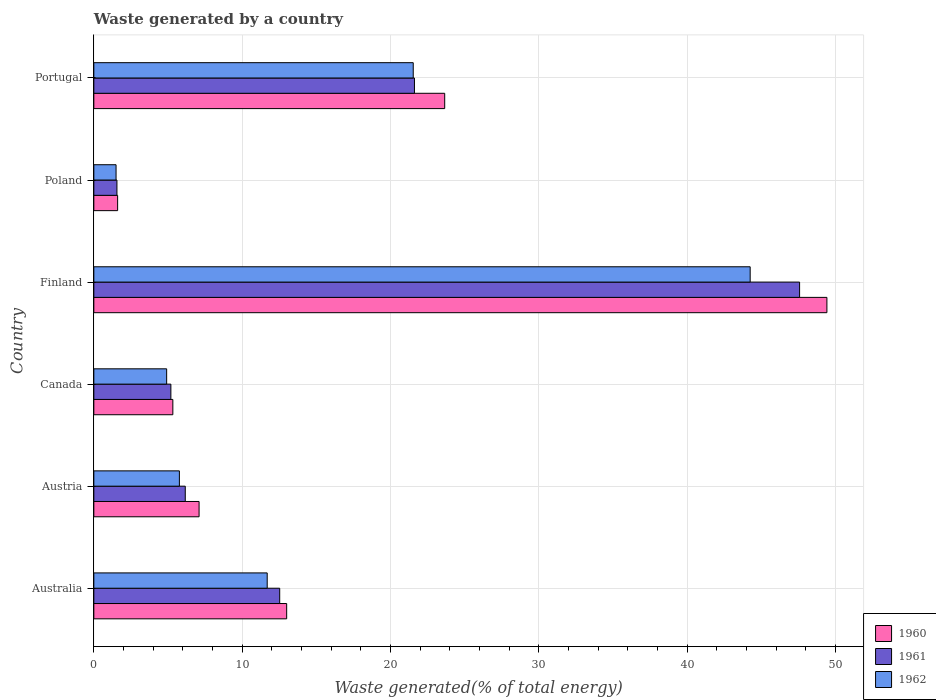Are the number of bars on each tick of the Y-axis equal?
Keep it short and to the point. Yes. How many bars are there on the 3rd tick from the bottom?
Offer a very short reply. 3. What is the label of the 6th group of bars from the top?
Offer a terse response. Australia. In how many cases, is the number of bars for a given country not equal to the number of legend labels?
Provide a short and direct response. 0. What is the total waste generated in 1960 in Finland?
Provide a succinct answer. 49.42. Across all countries, what is the maximum total waste generated in 1962?
Offer a very short reply. 44.25. Across all countries, what is the minimum total waste generated in 1961?
Offer a terse response. 1.56. In which country was the total waste generated in 1960 minimum?
Give a very brief answer. Poland. What is the total total waste generated in 1962 in the graph?
Give a very brief answer. 89.65. What is the difference between the total waste generated in 1960 in Austria and that in Portugal?
Offer a terse response. -16.56. What is the difference between the total waste generated in 1962 in Portugal and the total waste generated in 1960 in Australia?
Keep it short and to the point. 8.53. What is the average total waste generated in 1961 per country?
Your answer should be compact. 15.77. What is the difference between the total waste generated in 1961 and total waste generated in 1960 in Finland?
Provide a succinct answer. -1.84. What is the ratio of the total waste generated in 1960 in Austria to that in Finland?
Offer a very short reply. 0.14. What is the difference between the highest and the second highest total waste generated in 1960?
Make the answer very short. 25.77. What is the difference between the highest and the lowest total waste generated in 1962?
Offer a very short reply. 42.75. Is the sum of the total waste generated in 1962 in Austria and Portugal greater than the maximum total waste generated in 1960 across all countries?
Your answer should be compact. No. Is it the case that in every country, the sum of the total waste generated in 1961 and total waste generated in 1962 is greater than the total waste generated in 1960?
Your answer should be very brief. Yes. How many bars are there?
Offer a terse response. 18. How many countries are there in the graph?
Provide a short and direct response. 6. Does the graph contain grids?
Offer a terse response. Yes. How many legend labels are there?
Ensure brevity in your answer.  3. How are the legend labels stacked?
Your answer should be compact. Vertical. What is the title of the graph?
Provide a succinct answer. Waste generated by a country. Does "2000" appear as one of the legend labels in the graph?
Give a very brief answer. No. What is the label or title of the X-axis?
Give a very brief answer. Waste generated(% of total energy). What is the Waste generated(% of total energy) of 1960 in Australia?
Offer a terse response. 13. What is the Waste generated(% of total energy) in 1961 in Australia?
Offer a terse response. 12.53. What is the Waste generated(% of total energy) in 1962 in Australia?
Make the answer very short. 11.69. What is the Waste generated(% of total energy) in 1960 in Austria?
Offer a terse response. 7.1. What is the Waste generated(% of total energy) of 1961 in Austria?
Keep it short and to the point. 6.16. What is the Waste generated(% of total energy) of 1962 in Austria?
Offer a very short reply. 5.77. What is the Waste generated(% of total energy) of 1960 in Canada?
Your answer should be very brief. 5.33. What is the Waste generated(% of total energy) in 1961 in Canada?
Keep it short and to the point. 5.19. What is the Waste generated(% of total energy) of 1962 in Canada?
Offer a terse response. 4.91. What is the Waste generated(% of total energy) of 1960 in Finland?
Your answer should be compact. 49.42. What is the Waste generated(% of total energy) of 1961 in Finland?
Provide a short and direct response. 47.58. What is the Waste generated(% of total energy) of 1962 in Finland?
Your response must be concise. 44.25. What is the Waste generated(% of total energy) in 1960 in Poland?
Your answer should be very brief. 1.6. What is the Waste generated(% of total energy) of 1961 in Poland?
Provide a succinct answer. 1.56. What is the Waste generated(% of total energy) of 1962 in Poland?
Offer a terse response. 1.5. What is the Waste generated(% of total energy) of 1960 in Portugal?
Your response must be concise. 23.66. What is the Waste generated(% of total energy) of 1961 in Portugal?
Offer a terse response. 21.62. What is the Waste generated(% of total energy) in 1962 in Portugal?
Provide a succinct answer. 21.53. Across all countries, what is the maximum Waste generated(% of total energy) in 1960?
Ensure brevity in your answer.  49.42. Across all countries, what is the maximum Waste generated(% of total energy) of 1961?
Your answer should be compact. 47.58. Across all countries, what is the maximum Waste generated(% of total energy) in 1962?
Your response must be concise. 44.25. Across all countries, what is the minimum Waste generated(% of total energy) in 1960?
Keep it short and to the point. 1.6. Across all countries, what is the minimum Waste generated(% of total energy) in 1961?
Make the answer very short. 1.56. Across all countries, what is the minimum Waste generated(% of total energy) of 1962?
Your answer should be very brief. 1.5. What is the total Waste generated(% of total energy) in 1960 in the graph?
Provide a short and direct response. 100.11. What is the total Waste generated(% of total energy) of 1961 in the graph?
Your response must be concise. 94.65. What is the total Waste generated(% of total energy) in 1962 in the graph?
Make the answer very short. 89.65. What is the difference between the Waste generated(% of total energy) of 1960 in Australia and that in Austria?
Give a very brief answer. 5.9. What is the difference between the Waste generated(% of total energy) of 1961 in Australia and that in Austria?
Provide a short and direct response. 6.37. What is the difference between the Waste generated(% of total energy) in 1962 in Australia and that in Austria?
Give a very brief answer. 5.92. What is the difference between the Waste generated(% of total energy) of 1960 in Australia and that in Canada?
Make the answer very short. 7.67. What is the difference between the Waste generated(% of total energy) of 1961 in Australia and that in Canada?
Keep it short and to the point. 7.34. What is the difference between the Waste generated(% of total energy) of 1962 in Australia and that in Canada?
Give a very brief answer. 6.78. What is the difference between the Waste generated(% of total energy) of 1960 in Australia and that in Finland?
Ensure brevity in your answer.  -36.42. What is the difference between the Waste generated(% of total energy) of 1961 in Australia and that in Finland?
Your response must be concise. -35.05. What is the difference between the Waste generated(% of total energy) of 1962 in Australia and that in Finland?
Your answer should be very brief. -32.56. What is the difference between the Waste generated(% of total energy) of 1960 in Australia and that in Poland?
Provide a succinct answer. 11.4. What is the difference between the Waste generated(% of total energy) in 1961 in Australia and that in Poland?
Your answer should be compact. 10.97. What is the difference between the Waste generated(% of total energy) of 1962 in Australia and that in Poland?
Offer a terse response. 10.19. What is the difference between the Waste generated(% of total energy) in 1960 in Australia and that in Portugal?
Offer a very short reply. -10.65. What is the difference between the Waste generated(% of total energy) of 1961 in Australia and that in Portugal?
Ensure brevity in your answer.  -9.09. What is the difference between the Waste generated(% of total energy) of 1962 in Australia and that in Portugal?
Offer a terse response. -9.84. What is the difference between the Waste generated(% of total energy) in 1960 in Austria and that in Canada?
Offer a very short reply. 1.77. What is the difference between the Waste generated(% of total energy) of 1961 in Austria and that in Canada?
Give a very brief answer. 0.97. What is the difference between the Waste generated(% of total energy) in 1962 in Austria and that in Canada?
Keep it short and to the point. 0.86. What is the difference between the Waste generated(% of total energy) in 1960 in Austria and that in Finland?
Offer a very short reply. -42.33. What is the difference between the Waste generated(% of total energy) in 1961 in Austria and that in Finland?
Provide a succinct answer. -41.42. What is the difference between the Waste generated(% of total energy) in 1962 in Austria and that in Finland?
Give a very brief answer. -38.48. What is the difference between the Waste generated(% of total energy) of 1960 in Austria and that in Poland?
Keep it short and to the point. 5.49. What is the difference between the Waste generated(% of total energy) in 1961 in Austria and that in Poland?
Make the answer very short. 4.61. What is the difference between the Waste generated(% of total energy) in 1962 in Austria and that in Poland?
Your response must be concise. 4.27. What is the difference between the Waste generated(% of total energy) in 1960 in Austria and that in Portugal?
Offer a terse response. -16.56. What is the difference between the Waste generated(% of total energy) of 1961 in Austria and that in Portugal?
Keep it short and to the point. -15.45. What is the difference between the Waste generated(% of total energy) in 1962 in Austria and that in Portugal?
Offer a terse response. -15.76. What is the difference between the Waste generated(% of total energy) in 1960 in Canada and that in Finland?
Your answer should be very brief. -44.1. What is the difference between the Waste generated(% of total energy) of 1961 in Canada and that in Finland?
Offer a very short reply. -42.39. What is the difference between the Waste generated(% of total energy) in 1962 in Canada and that in Finland?
Provide a short and direct response. -39.34. What is the difference between the Waste generated(% of total energy) of 1960 in Canada and that in Poland?
Offer a terse response. 3.72. What is the difference between the Waste generated(% of total energy) in 1961 in Canada and that in Poland?
Offer a very short reply. 3.64. What is the difference between the Waste generated(% of total energy) in 1962 in Canada and that in Poland?
Make the answer very short. 3.41. What is the difference between the Waste generated(% of total energy) in 1960 in Canada and that in Portugal?
Give a very brief answer. -18.33. What is the difference between the Waste generated(% of total energy) of 1961 in Canada and that in Portugal?
Offer a terse response. -16.42. What is the difference between the Waste generated(% of total energy) of 1962 in Canada and that in Portugal?
Provide a succinct answer. -16.62. What is the difference between the Waste generated(% of total energy) in 1960 in Finland and that in Poland?
Make the answer very short. 47.82. What is the difference between the Waste generated(% of total energy) in 1961 in Finland and that in Poland?
Provide a short and direct response. 46.02. What is the difference between the Waste generated(% of total energy) of 1962 in Finland and that in Poland?
Your answer should be compact. 42.75. What is the difference between the Waste generated(% of total energy) in 1960 in Finland and that in Portugal?
Offer a very short reply. 25.77. What is the difference between the Waste generated(% of total energy) of 1961 in Finland and that in Portugal?
Your response must be concise. 25.96. What is the difference between the Waste generated(% of total energy) in 1962 in Finland and that in Portugal?
Offer a terse response. 22.72. What is the difference between the Waste generated(% of total energy) of 1960 in Poland and that in Portugal?
Offer a very short reply. -22.05. What is the difference between the Waste generated(% of total energy) of 1961 in Poland and that in Portugal?
Make the answer very short. -20.06. What is the difference between the Waste generated(% of total energy) in 1962 in Poland and that in Portugal?
Keep it short and to the point. -20.03. What is the difference between the Waste generated(% of total energy) of 1960 in Australia and the Waste generated(% of total energy) of 1961 in Austria?
Provide a succinct answer. 6.84. What is the difference between the Waste generated(% of total energy) of 1960 in Australia and the Waste generated(% of total energy) of 1962 in Austria?
Make the answer very short. 7.23. What is the difference between the Waste generated(% of total energy) in 1961 in Australia and the Waste generated(% of total energy) in 1962 in Austria?
Provide a succinct answer. 6.76. What is the difference between the Waste generated(% of total energy) of 1960 in Australia and the Waste generated(% of total energy) of 1961 in Canada?
Provide a short and direct response. 7.81. What is the difference between the Waste generated(% of total energy) in 1960 in Australia and the Waste generated(% of total energy) in 1962 in Canada?
Your response must be concise. 8.09. What is the difference between the Waste generated(% of total energy) in 1961 in Australia and the Waste generated(% of total energy) in 1962 in Canada?
Keep it short and to the point. 7.62. What is the difference between the Waste generated(% of total energy) in 1960 in Australia and the Waste generated(% of total energy) in 1961 in Finland?
Ensure brevity in your answer.  -34.58. What is the difference between the Waste generated(% of total energy) of 1960 in Australia and the Waste generated(% of total energy) of 1962 in Finland?
Offer a terse response. -31.25. What is the difference between the Waste generated(% of total energy) in 1961 in Australia and the Waste generated(% of total energy) in 1962 in Finland?
Offer a terse response. -31.72. What is the difference between the Waste generated(% of total energy) in 1960 in Australia and the Waste generated(% of total energy) in 1961 in Poland?
Your answer should be very brief. 11.44. What is the difference between the Waste generated(% of total energy) in 1960 in Australia and the Waste generated(% of total energy) in 1962 in Poland?
Offer a very short reply. 11.5. What is the difference between the Waste generated(% of total energy) of 1961 in Australia and the Waste generated(% of total energy) of 1962 in Poland?
Provide a succinct answer. 11.03. What is the difference between the Waste generated(% of total energy) in 1960 in Australia and the Waste generated(% of total energy) in 1961 in Portugal?
Offer a terse response. -8.62. What is the difference between the Waste generated(% of total energy) of 1960 in Australia and the Waste generated(% of total energy) of 1962 in Portugal?
Provide a short and direct response. -8.53. What is the difference between the Waste generated(% of total energy) in 1961 in Australia and the Waste generated(% of total energy) in 1962 in Portugal?
Make the answer very short. -9. What is the difference between the Waste generated(% of total energy) in 1960 in Austria and the Waste generated(% of total energy) in 1961 in Canada?
Keep it short and to the point. 1.9. What is the difference between the Waste generated(% of total energy) of 1960 in Austria and the Waste generated(% of total energy) of 1962 in Canada?
Provide a short and direct response. 2.19. What is the difference between the Waste generated(% of total energy) in 1961 in Austria and the Waste generated(% of total energy) in 1962 in Canada?
Ensure brevity in your answer.  1.25. What is the difference between the Waste generated(% of total energy) in 1960 in Austria and the Waste generated(% of total energy) in 1961 in Finland?
Offer a terse response. -40.48. What is the difference between the Waste generated(% of total energy) in 1960 in Austria and the Waste generated(% of total energy) in 1962 in Finland?
Make the answer very short. -37.15. What is the difference between the Waste generated(% of total energy) in 1961 in Austria and the Waste generated(% of total energy) in 1962 in Finland?
Give a very brief answer. -38.09. What is the difference between the Waste generated(% of total energy) of 1960 in Austria and the Waste generated(% of total energy) of 1961 in Poland?
Keep it short and to the point. 5.54. What is the difference between the Waste generated(% of total energy) in 1960 in Austria and the Waste generated(% of total energy) in 1962 in Poland?
Your response must be concise. 5.6. What is the difference between the Waste generated(% of total energy) in 1961 in Austria and the Waste generated(% of total energy) in 1962 in Poland?
Your answer should be compact. 4.67. What is the difference between the Waste generated(% of total energy) of 1960 in Austria and the Waste generated(% of total energy) of 1961 in Portugal?
Offer a terse response. -14.52. What is the difference between the Waste generated(% of total energy) of 1960 in Austria and the Waste generated(% of total energy) of 1962 in Portugal?
Your response must be concise. -14.44. What is the difference between the Waste generated(% of total energy) in 1961 in Austria and the Waste generated(% of total energy) in 1962 in Portugal?
Provide a short and direct response. -15.37. What is the difference between the Waste generated(% of total energy) in 1960 in Canada and the Waste generated(% of total energy) in 1961 in Finland?
Provide a short and direct response. -42.25. What is the difference between the Waste generated(% of total energy) in 1960 in Canada and the Waste generated(% of total energy) in 1962 in Finland?
Your response must be concise. -38.92. What is the difference between the Waste generated(% of total energy) in 1961 in Canada and the Waste generated(% of total energy) in 1962 in Finland?
Provide a short and direct response. -39.06. What is the difference between the Waste generated(% of total energy) in 1960 in Canada and the Waste generated(% of total energy) in 1961 in Poland?
Offer a very short reply. 3.77. What is the difference between the Waste generated(% of total energy) of 1960 in Canada and the Waste generated(% of total energy) of 1962 in Poland?
Offer a very short reply. 3.83. What is the difference between the Waste generated(% of total energy) in 1961 in Canada and the Waste generated(% of total energy) in 1962 in Poland?
Give a very brief answer. 3.7. What is the difference between the Waste generated(% of total energy) in 1960 in Canada and the Waste generated(% of total energy) in 1961 in Portugal?
Offer a terse response. -16.29. What is the difference between the Waste generated(% of total energy) of 1960 in Canada and the Waste generated(% of total energy) of 1962 in Portugal?
Offer a terse response. -16.21. What is the difference between the Waste generated(% of total energy) of 1961 in Canada and the Waste generated(% of total energy) of 1962 in Portugal?
Give a very brief answer. -16.34. What is the difference between the Waste generated(% of total energy) of 1960 in Finland and the Waste generated(% of total energy) of 1961 in Poland?
Give a very brief answer. 47.86. What is the difference between the Waste generated(% of total energy) of 1960 in Finland and the Waste generated(% of total energy) of 1962 in Poland?
Your response must be concise. 47.92. What is the difference between the Waste generated(% of total energy) of 1961 in Finland and the Waste generated(% of total energy) of 1962 in Poland?
Provide a succinct answer. 46.08. What is the difference between the Waste generated(% of total energy) in 1960 in Finland and the Waste generated(% of total energy) in 1961 in Portugal?
Ensure brevity in your answer.  27.81. What is the difference between the Waste generated(% of total energy) of 1960 in Finland and the Waste generated(% of total energy) of 1962 in Portugal?
Offer a very short reply. 27.89. What is the difference between the Waste generated(% of total energy) in 1961 in Finland and the Waste generated(% of total energy) in 1962 in Portugal?
Give a very brief answer. 26.05. What is the difference between the Waste generated(% of total energy) in 1960 in Poland and the Waste generated(% of total energy) in 1961 in Portugal?
Your response must be concise. -20.01. What is the difference between the Waste generated(% of total energy) of 1960 in Poland and the Waste generated(% of total energy) of 1962 in Portugal?
Keep it short and to the point. -19.93. What is the difference between the Waste generated(% of total energy) of 1961 in Poland and the Waste generated(% of total energy) of 1962 in Portugal?
Your answer should be very brief. -19.98. What is the average Waste generated(% of total energy) in 1960 per country?
Offer a terse response. 16.68. What is the average Waste generated(% of total energy) in 1961 per country?
Ensure brevity in your answer.  15.77. What is the average Waste generated(% of total energy) in 1962 per country?
Your response must be concise. 14.94. What is the difference between the Waste generated(% of total energy) in 1960 and Waste generated(% of total energy) in 1961 in Australia?
Your response must be concise. 0.47. What is the difference between the Waste generated(% of total energy) in 1960 and Waste generated(% of total energy) in 1962 in Australia?
Provide a succinct answer. 1.31. What is the difference between the Waste generated(% of total energy) of 1961 and Waste generated(% of total energy) of 1962 in Australia?
Give a very brief answer. 0.84. What is the difference between the Waste generated(% of total energy) in 1960 and Waste generated(% of total energy) in 1961 in Austria?
Ensure brevity in your answer.  0.93. What is the difference between the Waste generated(% of total energy) of 1960 and Waste generated(% of total energy) of 1962 in Austria?
Provide a short and direct response. 1.33. What is the difference between the Waste generated(% of total energy) in 1961 and Waste generated(% of total energy) in 1962 in Austria?
Provide a short and direct response. 0.4. What is the difference between the Waste generated(% of total energy) of 1960 and Waste generated(% of total energy) of 1961 in Canada?
Offer a terse response. 0.13. What is the difference between the Waste generated(% of total energy) in 1960 and Waste generated(% of total energy) in 1962 in Canada?
Keep it short and to the point. 0.42. What is the difference between the Waste generated(% of total energy) in 1961 and Waste generated(% of total energy) in 1962 in Canada?
Make the answer very short. 0.28. What is the difference between the Waste generated(% of total energy) in 1960 and Waste generated(% of total energy) in 1961 in Finland?
Offer a very short reply. 1.84. What is the difference between the Waste generated(% of total energy) in 1960 and Waste generated(% of total energy) in 1962 in Finland?
Keep it short and to the point. 5.17. What is the difference between the Waste generated(% of total energy) of 1961 and Waste generated(% of total energy) of 1962 in Finland?
Provide a short and direct response. 3.33. What is the difference between the Waste generated(% of total energy) of 1960 and Waste generated(% of total energy) of 1961 in Poland?
Offer a very short reply. 0.05. What is the difference between the Waste generated(% of total energy) in 1960 and Waste generated(% of total energy) in 1962 in Poland?
Make the answer very short. 0.11. What is the difference between the Waste generated(% of total energy) in 1961 and Waste generated(% of total energy) in 1962 in Poland?
Give a very brief answer. 0.06. What is the difference between the Waste generated(% of total energy) in 1960 and Waste generated(% of total energy) in 1961 in Portugal?
Give a very brief answer. 2.04. What is the difference between the Waste generated(% of total energy) of 1960 and Waste generated(% of total energy) of 1962 in Portugal?
Give a very brief answer. 2.12. What is the difference between the Waste generated(% of total energy) in 1961 and Waste generated(% of total energy) in 1962 in Portugal?
Your answer should be very brief. 0.08. What is the ratio of the Waste generated(% of total energy) of 1960 in Australia to that in Austria?
Your response must be concise. 1.83. What is the ratio of the Waste generated(% of total energy) in 1961 in Australia to that in Austria?
Offer a terse response. 2.03. What is the ratio of the Waste generated(% of total energy) in 1962 in Australia to that in Austria?
Make the answer very short. 2.03. What is the ratio of the Waste generated(% of total energy) of 1960 in Australia to that in Canada?
Provide a short and direct response. 2.44. What is the ratio of the Waste generated(% of total energy) in 1961 in Australia to that in Canada?
Keep it short and to the point. 2.41. What is the ratio of the Waste generated(% of total energy) in 1962 in Australia to that in Canada?
Offer a terse response. 2.38. What is the ratio of the Waste generated(% of total energy) of 1960 in Australia to that in Finland?
Offer a very short reply. 0.26. What is the ratio of the Waste generated(% of total energy) in 1961 in Australia to that in Finland?
Ensure brevity in your answer.  0.26. What is the ratio of the Waste generated(% of total energy) of 1962 in Australia to that in Finland?
Your response must be concise. 0.26. What is the ratio of the Waste generated(% of total energy) of 1960 in Australia to that in Poland?
Ensure brevity in your answer.  8.1. What is the ratio of the Waste generated(% of total energy) in 1961 in Australia to that in Poland?
Provide a short and direct response. 8.04. What is the ratio of the Waste generated(% of total energy) in 1962 in Australia to that in Poland?
Give a very brief answer. 7.8. What is the ratio of the Waste generated(% of total energy) of 1960 in Australia to that in Portugal?
Your answer should be compact. 0.55. What is the ratio of the Waste generated(% of total energy) of 1961 in Australia to that in Portugal?
Your response must be concise. 0.58. What is the ratio of the Waste generated(% of total energy) of 1962 in Australia to that in Portugal?
Give a very brief answer. 0.54. What is the ratio of the Waste generated(% of total energy) of 1960 in Austria to that in Canada?
Your answer should be compact. 1.33. What is the ratio of the Waste generated(% of total energy) in 1961 in Austria to that in Canada?
Provide a short and direct response. 1.19. What is the ratio of the Waste generated(% of total energy) of 1962 in Austria to that in Canada?
Your answer should be compact. 1.17. What is the ratio of the Waste generated(% of total energy) of 1960 in Austria to that in Finland?
Your answer should be compact. 0.14. What is the ratio of the Waste generated(% of total energy) in 1961 in Austria to that in Finland?
Your answer should be compact. 0.13. What is the ratio of the Waste generated(% of total energy) in 1962 in Austria to that in Finland?
Give a very brief answer. 0.13. What is the ratio of the Waste generated(% of total energy) of 1960 in Austria to that in Poland?
Your answer should be very brief. 4.42. What is the ratio of the Waste generated(% of total energy) in 1961 in Austria to that in Poland?
Provide a short and direct response. 3.96. What is the ratio of the Waste generated(% of total energy) in 1962 in Austria to that in Poland?
Your answer should be compact. 3.85. What is the ratio of the Waste generated(% of total energy) of 1960 in Austria to that in Portugal?
Your answer should be compact. 0.3. What is the ratio of the Waste generated(% of total energy) in 1961 in Austria to that in Portugal?
Offer a terse response. 0.29. What is the ratio of the Waste generated(% of total energy) of 1962 in Austria to that in Portugal?
Give a very brief answer. 0.27. What is the ratio of the Waste generated(% of total energy) in 1960 in Canada to that in Finland?
Keep it short and to the point. 0.11. What is the ratio of the Waste generated(% of total energy) in 1961 in Canada to that in Finland?
Your response must be concise. 0.11. What is the ratio of the Waste generated(% of total energy) of 1962 in Canada to that in Finland?
Give a very brief answer. 0.11. What is the ratio of the Waste generated(% of total energy) of 1960 in Canada to that in Poland?
Ensure brevity in your answer.  3.32. What is the ratio of the Waste generated(% of total energy) in 1961 in Canada to that in Poland?
Give a very brief answer. 3.33. What is the ratio of the Waste generated(% of total energy) in 1962 in Canada to that in Poland?
Your response must be concise. 3.28. What is the ratio of the Waste generated(% of total energy) in 1960 in Canada to that in Portugal?
Provide a short and direct response. 0.23. What is the ratio of the Waste generated(% of total energy) in 1961 in Canada to that in Portugal?
Keep it short and to the point. 0.24. What is the ratio of the Waste generated(% of total energy) of 1962 in Canada to that in Portugal?
Your answer should be compact. 0.23. What is the ratio of the Waste generated(% of total energy) in 1960 in Finland to that in Poland?
Provide a short and direct response. 30.8. What is the ratio of the Waste generated(% of total energy) of 1961 in Finland to that in Poland?
Offer a terse response. 30.53. What is the ratio of the Waste generated(% of total energy) of 1962 in Finland to that in Poland?
Your answer should be compact. 29.52. What is the ratio of the Waste generated(% of total energy) in 1960 in Finland to that in Portugal?
Provide a short and direct response. 2.09. What is the ratio of the Waste generated(% of total energy) in 1961 in Finland to that in Portugal?
Ensure brevity in your answer.  2.2. What is the ratio of the Waste generated(% of total energy) of 1962 in Finland to that in Portugal?
Make the answer very short. 2.05. What is the ratio of the Waste generated(% of total energy) in 1960 in Poland to that in Portugal?
Make the answer very short. 0.07. What is the ratio of the Waste generated(% of total energy) of 1961 in Poland to that in Portugal?
Provide a succinct answer. 0.07. What is the ratio of the Waste generated(% of total energy) of 1962 in Poland to that in Portugal?
Ensure brevity in your answer.  0.07. What is the difference between the highest and the second highest Waste generated(% of total energy) of 1960?
Your answer should be compact. 25.77. What is the difference between the highest and the second highest Waste generated(% of total energy) of 1961?
Offer a very short reply. 25.96. What is the difference between the highest and the second highest Waste generated(% of total energy) in 1962?
Ensure brevity in your answer.  22.72. What is the difference between the highest and the lowest Waste generated(% of total energy) of 1960?
Make the answer very short. 47.82. What is the difference between the highest and the lowest Waste generated(% of total energy) in 1961?
Make the answer very short. 46.02. What is the difference between the highest and the lowest Waste generated(% of total energy) of 1962?
Make the answer very short. 42.75. 